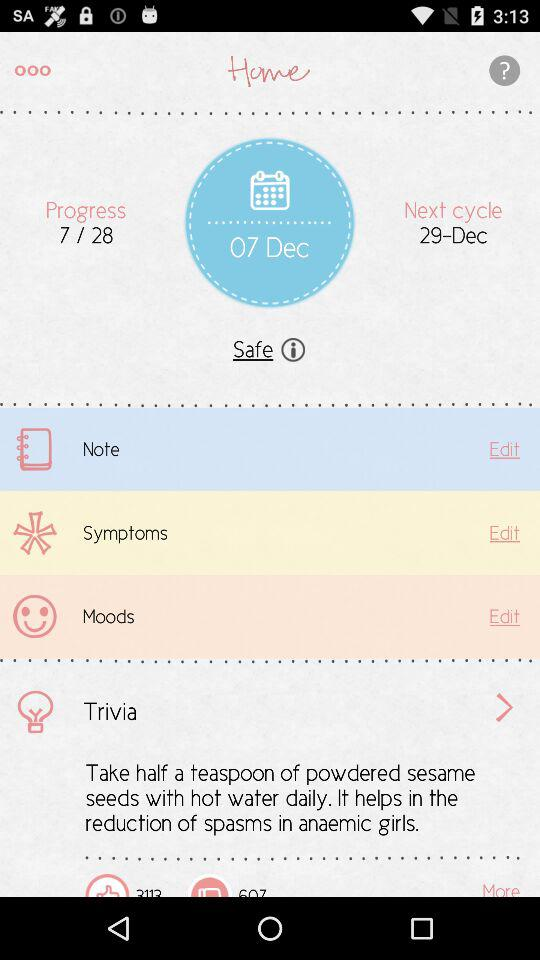What is the date? The date is December 7. 